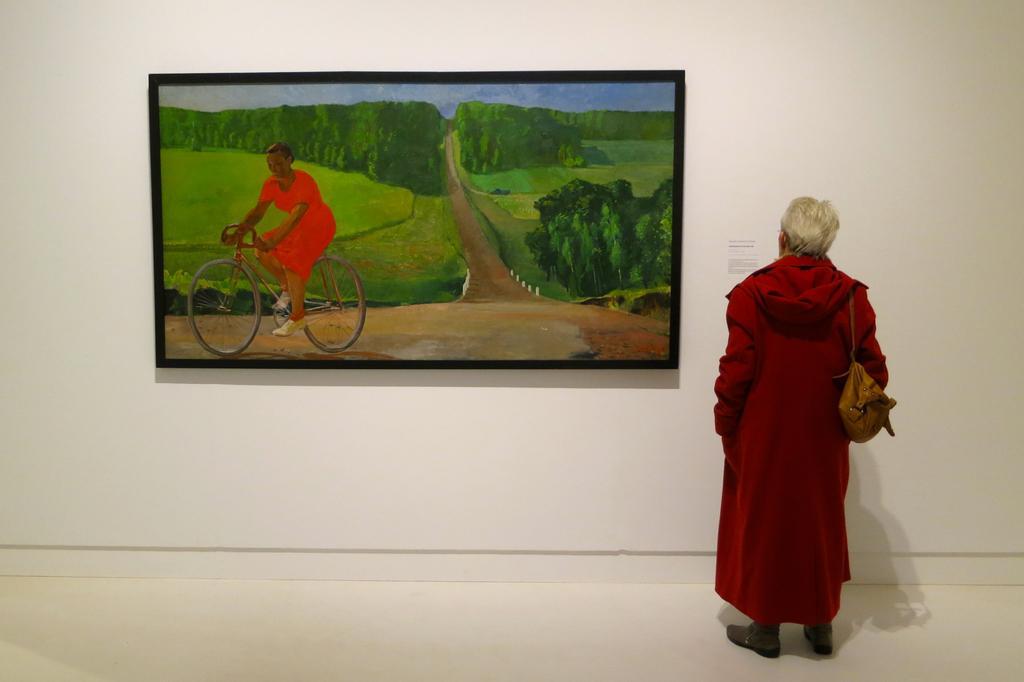In one or two sentences, can you explain what this image depicts? In this picture there is a person standing. At the back there is a board on the wall and there is a picture of a woman riding bicycle and there are trees. At the top there is sky. At the bottom there is grass and there is a road and there is a paper on the wall and there is text on the paper. At the bottom there is a floor. 